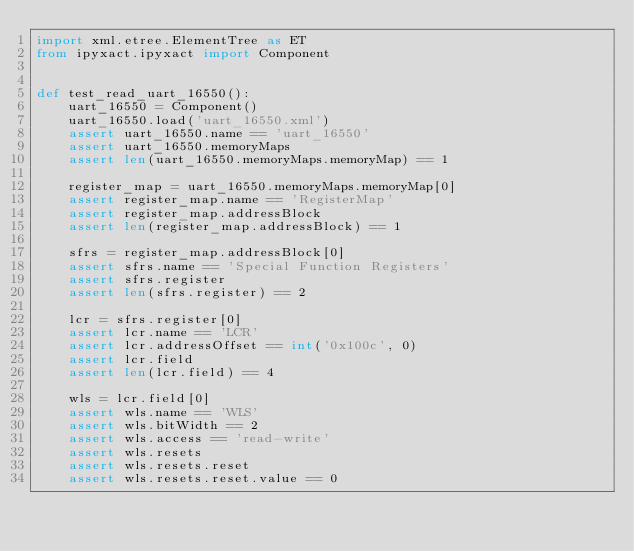<code> <loc_0><loc_0><loc_500><loc_500><_Python_>import xml.etree.ElementTree as ET
from ipyxact.ipyxact import Component


def test_read_uart_16550():
    uart_16550 = Component()
    uart_16550.load('uart_16550.xml')
    assert uart_16550.name == 'uart_16550'
    assert uart_16550.memoryMaps
    assert len(uart_16550.memoryMaps.memoryMap) == 1

    register_map = uart_16550.memoryMaps.memoryMap[0]
    assert register_map.name == 'RegisterMap'
    assert register_map.addressBlock
    assert len(register_map.addressBlock) == 1

    sfrs = register_map.addressBlock[0]
    assert sfrs.name == 'Special Function Registers'
    assert sfrs.register
    assert len(sfrs.register) == 2

    lcr = sfrs.register[0]
    assert lcr.name == 'LCR'
    assert lcr.addressOffset == int('0x100c', 0)
    assert lcr.field
    assert len(lcr.field) == 4

    wls = lcr.field[0]
    assert wls.name == 'WLS'
    assert wls.bitWidth == 2
    assert wls.access == 'read-write'
    assert wls.resets
    assert wls.resets.reset
    assert wls.resets.reset.value == 0
</code> 